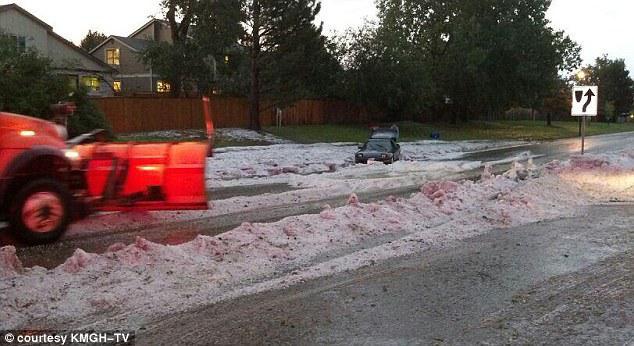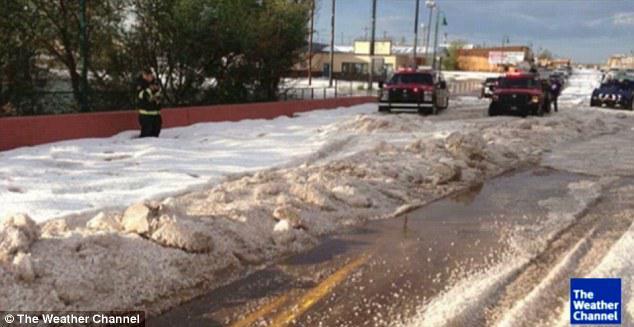The first image is the image on the left, the second image is the image on the right. Assess this claim about the two images: "In the right image a snow plow is plowing snow.". Correct or not? Answer yes or no. No. 